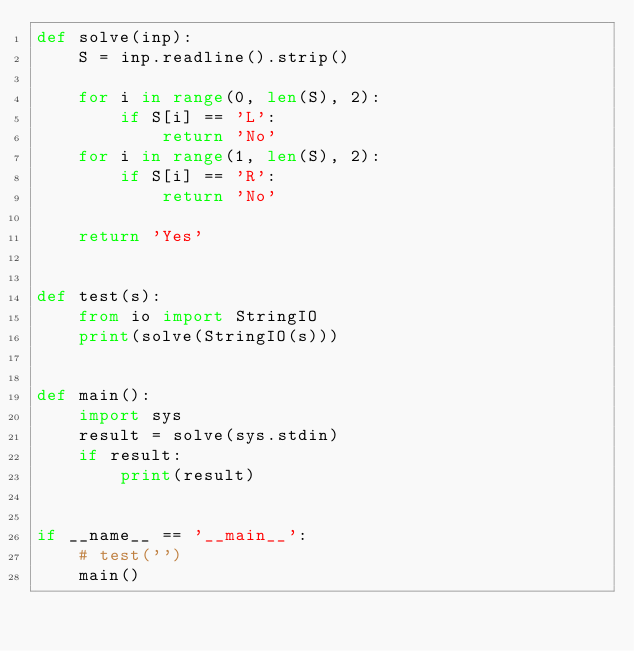Convert code to text. <code><loc_0><loc_0><loc_500><loc_500><_Python_>def solve(inp):
    S = inp.readline().strip()

    for i in range(0, len(S), 2):
        if S[i] == 'L':
            return 'No'
    for i in range(1, len(S), 2):
        if S[i] == 'R':
            return 'No'

    return 'Yes'


def test(s):
    from io import StringIO
    print(solve(StringIO(s)))


def main():
    import sys
    result = solve(sys.stdin)
    if result:
        print(result)


if __name__ == '__main__':
    # test('')
    main()
</code> 